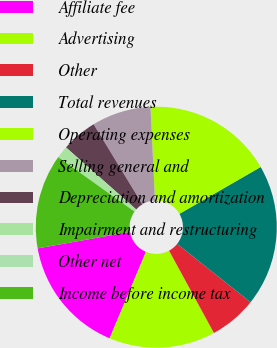Convert chart. <chart><loc_0><loc_0><loc_500><loc_500><pie_chart><fcel>Affiliate fee<fcel>Advertising<fcel>Other<fcel>Total revenues<fcel>Operating expenses<fcel>Selling general and<fcel>Depreciation and amortization<fcel>Impairment and restructuring<fcel>Other net<fcel>Income before income tax<nl><fcel>15.86%<fcel>14.27%<fcel>6.36%<fcel>19.02%<fcel>17.44%<fcel>7.94%<fcel>4.78%<fcel>1.61%<fcel>0.03%<fcel>12.69%<nl></chart> 